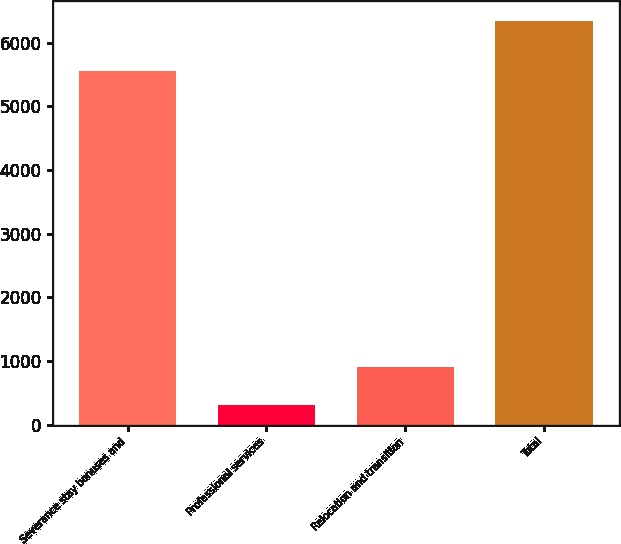<chart> <loc_0><loc_0><loc_500><loc_500><bar_chart><fcel>Severance stay bonuses and<fcel>Professional services<fcel>Relocation and transition<fcel>Total<nl><fcel>5550<fcel>310<fcel>913<fcel>6340<nl></chart> 